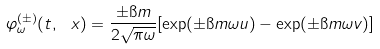Convert formula to latex. <formula><loc_0><loc_0><loc_500><loc_500>\varphi _ { \omega } ^ { ( \pm ) } ( t , \ x ) = \frac { \pm \i m } { 2 \sqrt { \pi \omega } } [ \exp ( \pm \i m \omega u ) - \exp ( \pm \i m \omega v ) ]</formula> 